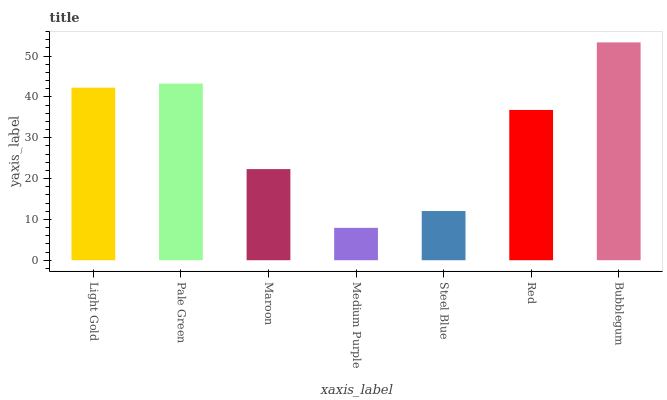Is Medium Purple the minimum?
Answer yes or no. Yes. Is Bubblegum the maximum?
Answer yes or no. Yes. Is Pale Green the minimum?
Answer yes or no. No. Is Pale Green the maximum?
Answer yes or no. No. Is Pale Green greater than Light Gold?
Answer yes or no. Yes. Is Light Gold less than Pale Green?
Answer yes or no. Yes. Is Light Gold greater than Pale Green?
Answer yes or no. No. Is Pale Green less than Light Gold?
Answer yes or no. No. Is Red the high median?
Answer yes or no. Yes. Is Red the low median?
Answer yes or no. Yes. Is Steel Blue the high median?
Answer yes or no. No. Is Medium Purple the low median?
Answer yes or no. No. 